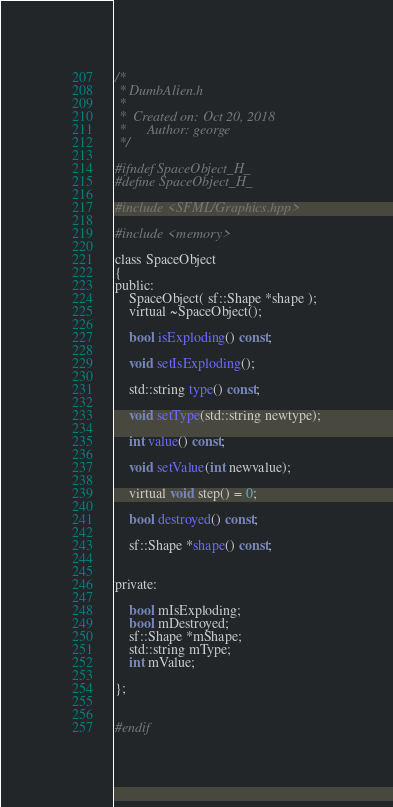Convert code to text. <code><loc_0><loc_0><loc_500><loc_500><_C_>/*
 * DumbAlien.h
 *
 *  Created on: Oct 20, 2018
 *      Author: george
 */

#ifndef SpaceObject_H_
#define SpaceObject_H_

#include <SFML/Graphics.hpp>

#include <memory>

class SpaceObject
{
public:
	SpaceObject( sf::Shape *shape );
	virtual ~SpaceObject();

	bool isExploding() const;
	
	void setIsExploding();
	
	std::string type() const;
	
	void setType(std::string newtype);
	
	int value() const;
	
	void setValue(int newvalue);
	
	virtual void step() = 0;

	bool destroyed() const;

	sf::Shape *shape() const;


private:

	bool mIsExploding;
	bool mDestroyed;
	sf::Shape *mShape;
	std::string mType;
	int mValue;

};


#endif
</code> 